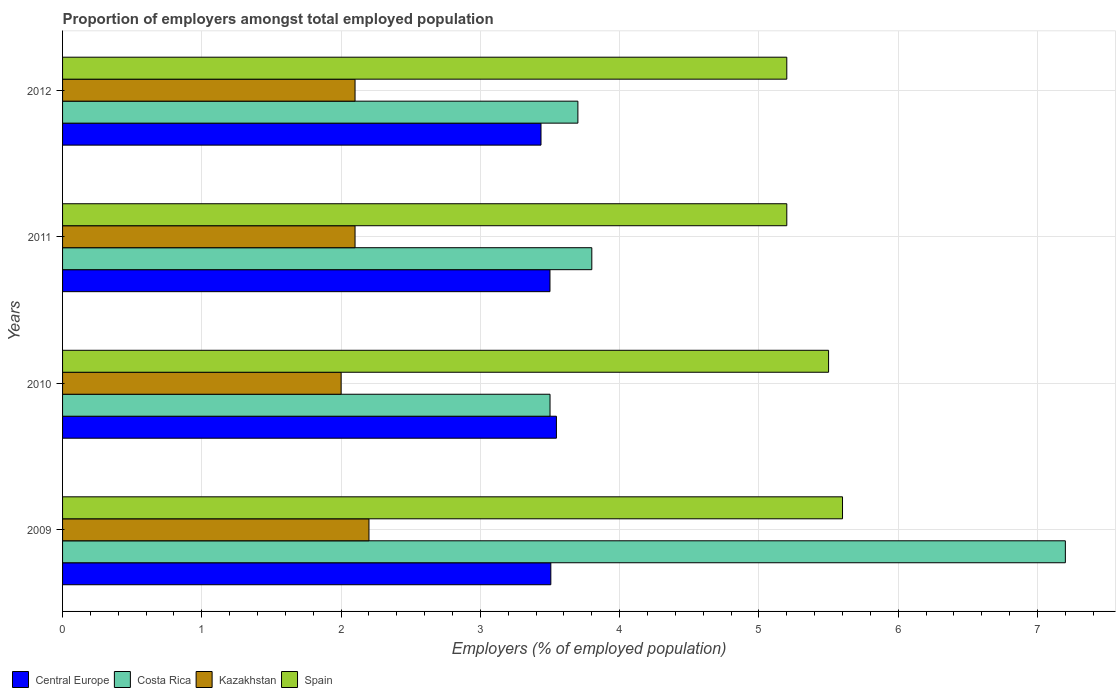How many groups of bars are there?
Offer a terse response. 4. Are the number of bars on each tick of the Y-axis equal?
Make the answer very short. Yes. What is the proportion of employers in Spain in 2010?
Offer a terse response. 5.5. Across all years, what is the maximum proportion of employers in Central Europe?
Provide a succinct answer. 3.55. Across all years, what is the minimum proportion of employers in Central Europe?
Keep it short and to the point. 3.44. In which year was the proportion of employers in Spain maximum?
Give a very brief answer. 2009. In which year was the proportion of employers in Kazakhstan minimum?
Give a very brief answer. 2010. What is the total proportion of employers in Central Europe in the graph?
Offer a terse response. 13.99. What is the difference between the proportion of employers in Costa Rica in 2009 and that in 2010?
Give a very brief answer. 3.7. What is the difference between the proportion of employers in Central Europe in 2011 and the proportion of employers in Costa Rica in 2012?
Provide a short and direct response. -0.2. What is the average proportion of employers in Kazakhstan per year?
Keep it short and to the point. 2.1. In the year 2010, what is the difference between the proportion of employers in Central Europe and proportion of employers in Costa Rica?
Offer a very short reply. 0.05. What is the ratio of the proportion of employers in Kazakhstan in 2010 to that in 2011?
Make the answer very short. 0.95. Is the proportion of employers in Spain in 2011 less than that in 2012?
Make the answer very short. No. Is the difference between the proportion of employers in Central Europe in 2009 and 2011 greater than the difference between the proportion of employers in Costa Rica in 2009 and 2011?
Your response must be concise. No. What is the difference between the highest and the second highest proportion of employers in Spain?
Give a very brief answer. 0.1. What is the difference between the highest and the lowest proportion of employers in Central Europe?
Your answer should be compact. 0.11. In how many years, is the proportion of employers in Central Europe greater than the average proportion of employers in Central Europe taken over all years?
Provide a succinct answer. 3. Is it the case that in every year, the sum of the proportion of employers in Kazakhstan and proportion of employers in Spain is greater than the sum of proportion of employers in Central Europe and proportion of employers in Costa Rica?
Ensure brevity in your answer.  No. What does the 3rd bar from the bottom in 2009 represents?
Give a very brief answer. Kazakhstan. What is the difference between two consecutive major ticks on the X-axis?
Keep it short and to the point. 1. Does the graph contain any zero values?
Offer a very short reply. No. Does the graph contain grids?
Provide a succinct answer. Yes. Where does the legend appear in the graph?
Offer a very short reply. Bottom left. How are the legend labels stacked?
Keep it short and to the point. Horizontal. What is the title of the graph?
Offer a terse response. Proportion of employers amongst total employed population. What is the label or title of the X-axis?
Your answer should be compact. Employers (% of employed population). What is the Employers (% of employed population) in Central Europe in 2009?
Make the answer very short. 3.51. What is the Employers (% of employed population) of Costa Rica in 2009?
Your response must be concise. 7.2. What is the Employers (% of employed population) of Kazakhstan in 2009?
Keep it short and to the point. 2.2. What is the Employers (% of employed population) of Spain in 2009?
Give a very brief answer. 5.6. What is the Employers (% of employed population) of Central Europe in 2010?
Keep it short and to the point. 3.55. What is the Employers (% of employed population) in Costa Rica in 2010?
Provide a succinct answer. 3.5. What is the Employers (% of employed population) in Kazakhstan in 2010?
Provide a short and direct response. 2. What is the Employers (% of employed population) in Central Europe in 2011?
Offer a very short reply. 3.5. What is the Employers (% of employed population) of Costa Rica in 2011?
Offer a terse response. 3.8. What is the Employers (% of employed population) in Kazakhstan in 2011?
Keep it short and to the point. 2.1. What is the Employers (% of employed population) in Spain in 2011?
Give a very brief answer. 5.2. What is the Employers (% of employed population) in Central Europe in 2012?
Ensure brevity in your answer.  3.44. What is the Employers (% of employed population) of Costa Rica in 2012?
Keep it short and to the point. 3.7. What is the Employers (% of employed population) in Kazakhstan in 2012?
Offer a terse response. 2.1. What is the Employers (% of employed population) of Spain in 2012?
Ensure brevity in your answer.  5.2. Across all years, what is the maximum Employers (% of employed population) of Central Europe?
Make the answer very short. 3.55. Across all years, what is the maximum Employers (% of employed population) in Costa Rica?
Provide a short and direct response. 7.2. Across all years, what is the maximum Employers (% of employed population) of Kazakhstan?
Offer a terse response. 2.2. Across all years, what is the maximum Employers (% of employed population) in Spain?
Make the answer very short. 5.6. Across all years, what is the minimum Employers (% of employed population) in Central Europe?
Provide a succinct answer. 3.44. Across all years, what is the minimum Employers (% of employed population) in Costa Rica?
Offer a terse response. 3.5. Across all years, what is the minimum Employers (% of employed population) of Kazakhstan?
Provide a succinct answer. 2. Across all years, what is the minimum Employers (% of employed population) in Spain?
Your response must be concise. 5.2. What is the total Employers (% of employed population) of Central Europe in the graph?
Your answer should be very brief. 13.99. What is the total Employers (% of employed population) of Kazakhstan in the graph?
Provide a succinct answer. 8.4. What is the total Employers (% of employed population) in Spain in the graph?
Your response must be concise. 21.5. What is the difference between the Employers (% of employed population) in Central Europe in 2009 and that in 2010?
Provide a succinct answer. -0.04. What is the difference between the Employers (% of employed population) of Costa Rica in 2009 and that in 2010?
Ensure brevity in your answer.  3.7. What is the difference between the Employers (% of employed population) of Kazakhstan in 2009 and that in 2010?
Your answer should be compact. 0.2. What is the difference between the Employers (% of employed population) of Central Europe in 2009 and that in 2011?
Your answer should be compact. 0.01. What is the difference between the Employers (% of employed population) in Spain in 2009 and that in 2011?
Your response must be concise. 0.4. What is the difference between the Employers (% of employed population) of Central Europe in 2009 and that in 2012?
Provide a succinct answer. 0.07. What is the difference between the Employers (% of employed population) of Spain in 2009 and that in 2012?
Give a very brief answer. 0.4. What is the difference between the Employers (% of employed population) of Central Europe in 2010 and that in 2011?
Your response must be concise. 0.05. What is the difference between the Employers (% of employed population) in Spain in 2010 and that in 2011?
Ensure brevity in your answer.  0.3. What is the difference between the Employers (% of employed population) in Central Europe in 2010 and that in 2012?
Your answer should be very brief. 0.11. What is the difference between the Employers (% of employed population) in Spain in 2010 and that in 2012?
Offer a very short reply. 0.3. What is the difference between the Employers (% of employed population) of Central Europe in 2011 and that in 2012?
Give a very brief answer. 0.06. What is the difference between the Employers (% of employed population) of Costa Rica in 2011 and that in 2012?
Ensure brevity in your answer.  0.1. What is the difference between the Employers (% of employed population) of Central Europe in 2009 and the Employers (% of employed population) of Costa Rica in 2010?
Make the answer very short. 0.01. What is the difference between the Employers (% of employed population) of Central Europe in 2009 and the Employers (% of employed population) of Kazakhstan in 2010?
Provide a succinct answer. 1.51. What is the difference between the Employers (% of employed population) in Central Europe in 2009 and the Employers (% of employed population) in Spain in 2010?
Your answer should be very brief. -1.99. What is the difference between the Employers (% of employed population) in Costa Rica in 2009 and the Employers (% of employed population) in Kazakhstan in 2010?
Make the answer very short. 5.2. What is the difference between the Employers (% of employed population) of Kazakhstan in 2009 and the Employers (% of employed population) of Spain in 2010?
Give a very brief answer. -3.3. What is the difference between the Employers (% of employed population) in Central Europe in 2009 and the Employers (% of employed population) in Costa Rica in 2011?
Offer a terse response. -0.29. What is the difference between the Employers (% of employed population) in Central Europe in 2009 and the Employers (% of employed population) in Kazakhstan in 2011?
Keep it short and to the point. 1.41. What is the difference between the Employers (% of employed population) in Central Europe in 2009 and the Employers (% of employed population) in Spain in 2011?
Give a very brief answer. -1.69. What is the difference between the Employers (% of employed population) in Costa Rica in 2009 and the Employers (% of employed population) in Kazakhstan in 2011?
Ensure brevity in your answer.  5.1. What is the difference between the Employers (% of employed population) of Costa Rica in 2009 and the Employers (% of employed population) of Spain in 2011?
Your response must be concise. 2. What is the difference between the Employers (% of employed population) in Kazakhstan in 2009 and the Employers (% of employed population) in Spain in 2011?
Your answer should be compact. -3. What is the difference between the Employers (% of employed population) in Central Europe in 2009 and the Employers (% of employed population) in Costa Rica in 2012?
Offer a very short reply. -0.19. What is the difference between the Employers (% of employed population) in Central Europe in 2009 and the Employers (% of employed population) in Kazakhstan in 2012?
Ensure brevity in your answer.  1.41. What is the difference between the Employers (% of employed population) in Central Europe in 2009 and the Employers (% of employed population) in Spain in 2012?
Offer a very short reply. -1.69. What is the difference between the Employers (% of employed population) in Costa Rica in 2009 and the Employers (% of employed population) in Spain in 2012?
Offer a terse response. 2. What is the difference between the Employers (% of employed population) of Central Europe in 2010 and the Employers (% of employed population) of Costa Rica in 2011?
Make the answer very short. -0.25. What is the difference between the Employers (% of employed population) of Central Europe in 2010 and the Employers (% of employed population) of Kazakhstan in 2011?
Keep it short and to the point. 1.45. What is the difference between the Employers (% of employed population) in Central Europe in 2010 and the Employers (% of employed population) in Spain in 2011?
Offer a very short reply. -1.65. What is the difference between the Employers (% of employed population) in Costa Rica in 2010 and the Employers (% of employed population) in Kazakhstan in 2011?
Your answer should be very brief. 1.4. What is the difference between the Employers (% of employed population) of Central Europe in 2010 and the Employers (% of employed population) of Costa Rica in 2012?
Provide a succinct answer. -0.15. What is the difference between the Employers (% of employed population) in Central Europe in 2010 and the Employers (% of employed population) in Kazakhstan in 2012?
Provide a short and direct response. 1.45. What is the difference between the Employers (% of employed population) of Central Europe in 2010 and the Employers (% of employed population) of Spain in 2012?
Your answer should be very brief. -1.65. What is the difference between the Employers (% of employed population) in Central Europe in 2011 and the Employers (% of employed population) in Costa Rica in 2012?
Keep it short and to the point. -0.2. What is the difference between the Employers (% of employed population) in Central Europe in 2011 and the Employers (% of employed population) in Kazakhstan in 2012?
Offer a terse response. 1.4. What is the difference between the Employers (% of employed population) in Central Europe in 2011 and the Employers (% of employed population) in Spain in 2012?
Provide a succinct answer. -1.7. What is the average Employers (% of employed population) of Central Europe per year?
Your answer should be compact. 3.5. What is the average Employers (% of employed population) of Costa Rica per year?
Keep it short and to the point. 4.55. What is the average Employers (% of employed population) of Kazakhstan per year?
Ensure brevity in your answer.  2.1. What is the average Employers (% of employed population) in Spain per year?
Provide a succinct answer. 5.38. In the year 2009, what is the difference between the Employers (% of employed population) of Central Europe and Employers (% of employed population) of Costa Rica?
Offer a very short reply. -3.69. In the year 2009, what is the difference between the Employers (% of employed population) in Central Europe and Employers (% of employed population) in Kazakhstan?
Offer a terse response. 1.31. In the year 2009, what is the difference between the Employers (% of employed population) in Central Europe and Employers (% of employed population) in Spain?
Your answer should be compact. -2.09. In the year 2009, what is the difference between the Employers (% of employed population) of Costa Rica and Employers (% of employed population) of Kazakhstan?
Ensure brevity in your answer.  5. In the year 2009, what is the difference between the Employers (% of employed population) of Kazakhstan and Employers (% of employed population) of Spain?
Ensure brevity in your answer.  -3.4. In the year 2010, what is the difference between the Employers (% of employed population) of Central Europe and Employers (% of employed population) of Costa Rica?
Your response must be concise. 0.05. In the year 2010, what is the difference between the Employers (% of employed population) of Central Europe and Employers (% of employed population) of Kazakhstan?
Give a very brief answer. 1.55. In the year 2010, what is the difference between the Employers (% of employed population) of Central Europe and Employers (% of employed population) of Spain?
Offer a terse response. -1.95. In the year 2010, what is the difference between the Employers (% of employed population) of Costa Rica and Employers (% of employed population) of Kazakhstan?
Your answer should be very brief. 1.5. In the year 2011, what is the difference between the Employers (% of employed population) of Central Europe and Employers (% of employed population) of Costa Rica?
Make the answer very short. -0.3. In the year 2011, what is the difference between the Employers (% of employed population) in Central Europe and Employers (% of employed population) in Kazakhstan?
Provide a short and direct response. 1.4. In the year 2011, what is the difference between the Employers (% of employed population) of Central Europe and Employers (% of employed population) of Spain?
Keep it short and to the point. -1.7. In the year 2011, what is the difference between the Employers (% of employed population) of Costa Rica and Employers (% of employed population) of Kazakhstan?
Your response must be concise. 1.7. In the year 2011, what is the difference between the Employers (% of employed population) of Costa Rica and Employers (% of employed population) of Spain?
Offer a very short reply. -1.4. In the year 2012, what is the difference between the Employers (% of employed population) of Central Europe and Employers (% of employed population) of Costa Rica?
Offer a very short reply. -0.26. In the year 2012, what is the difference between the Employers (% of employed population) of Central Europe and Employers (% of employed population) of Kazakhstan?
Provide a succinct answer. 1.34. In the year 2012, what is the difference between the Employers (% of employed population) of Central Europe and Employers (% of employed population) of Spain?
Your answer should be very brief. -1.76. In the year 2012, what is the difference between the Employers (% of employed population) in Costa Rica and Employers (% of employed population) in Spain?
Your response must be concise. -1.5. In the year 2012, what is the difference between the Employers (% of employed population) in Kazakhstan and Employers (% of employed population) in Spain?
Give a very brief answer. -3.1. What is the ratio of the Employers (% of employed population) in Central Europe in 2009 to that in 2010?
Your answer should be compact. 0.99. What is the ratio of the Employers (% of employed population) in Costa Rica in 2009 to that in 2010?
Keep it short and to the point. 2.06. What is the ratio of the Employers (% of employed population) in Spain in 2009 to that in 2010?
Provide a succinct answer. 1.02. What is the ratio of the Employers (% of employed population) in Costa Rica in 2009 to that in 2011?
Provide a succinct answer. 1.89. What is the ratio of the Employers (% of employed population) of Kazakhstan in 2009 to that in 2011?
Provide a succinct answer. 1.05. What is the ratio of the Employers (% of employed population) in Spain in 2009 to that in 2011?
Offer a very short reply. 1.08. What is the ratio of the Employers (% of employed population) of Central Europe in 2009 to that in 2012?
Your answer should be compact. 1.02. What is the ratio of the Employers (% of employed population) in Costa Rica in 2009 to that in 2012?
Offer a very short reply. 1.95. What is the ratio of the Employers (% of employed population) of Kazakhstan in 2009 to that in 2012?
Your answer should be very brief. 1.05. What is the ratio of the Employers (% of employed population) in Central Europe in 2010 to that in 2011?
Offer a terse response. 1.01. What is the ratio of the Employers (% of employed population) of Costa Rica in 2010 to that in 2011?
Your response must be concise. 0.92. What is the ratio of the Employers (% of employed population) of Spain in 2010 to that in 2011?
Your answer should be compact. 1.06. What is the ratio of the Employers (% of employed population) in Central Europe in 2010 to that in 2012?
Ensure brevity in your answer.  1.03. What is the ratio of the Employers (% of employed population) in Costa Rica in 2010 to that in 2012?
Ensure brevity in your answer.  0.95. What is the ratio of the Employers (% of employed population) of Spain in 2010 to that in 2012?
Provide a short and direct response. 1.06. What is the ratio of the Employers (% of employed population) of Central Europe in 2011 to that in 2012?
Provide a short and direct response. 1.02. What is the ratio of the Employers (% of employed population) of Costa Rica in 2011 to that in 2012?
Make the answer very short. 1.03. What is the difference between the highest and the second highest Employers (% of employed population) in Central Europe?
Ensure brevity in your answer.  0.04. What is the difference between the highest and the second highest Employers (% of employed population) in Costa Rica?
Make the answer very short. 3.4. What is the difference between the highest and the second highest Employers (% of employed population) of Kazakhstan?
Provide a short and direct response. 0.1. What is the difference between the highest and the lowest Employers (% of employed population) in Central Europe?
Make the answer very short. 0.11. 